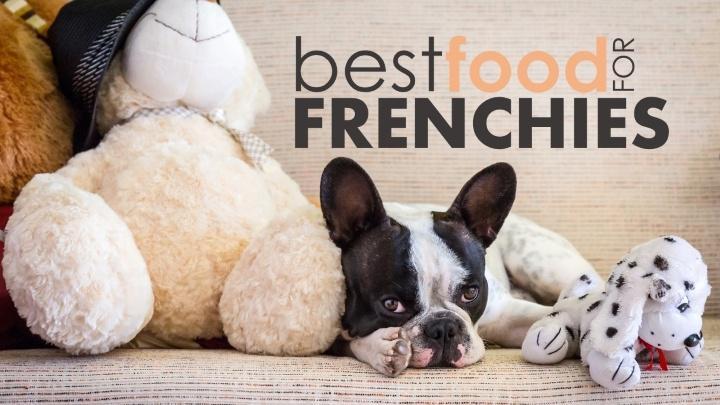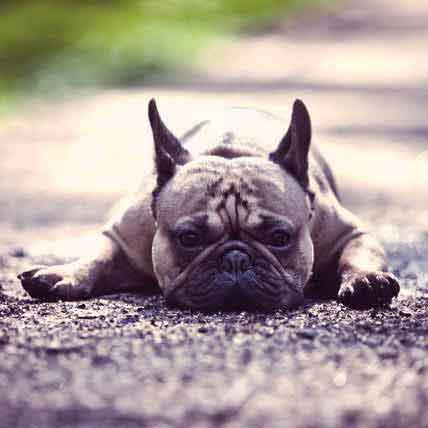The first image is the image on the left, the second image is the image on the right. Considering the images on both sides, is "One dog is wearing a bib." valid? Answer yes or no. No. The first image is the image on the left, the second image is the image on the right. Examine the images to the left and right. Is the description "There is a dog sitting in a pile of dog treats." accurate? Answer yes or no. No. 